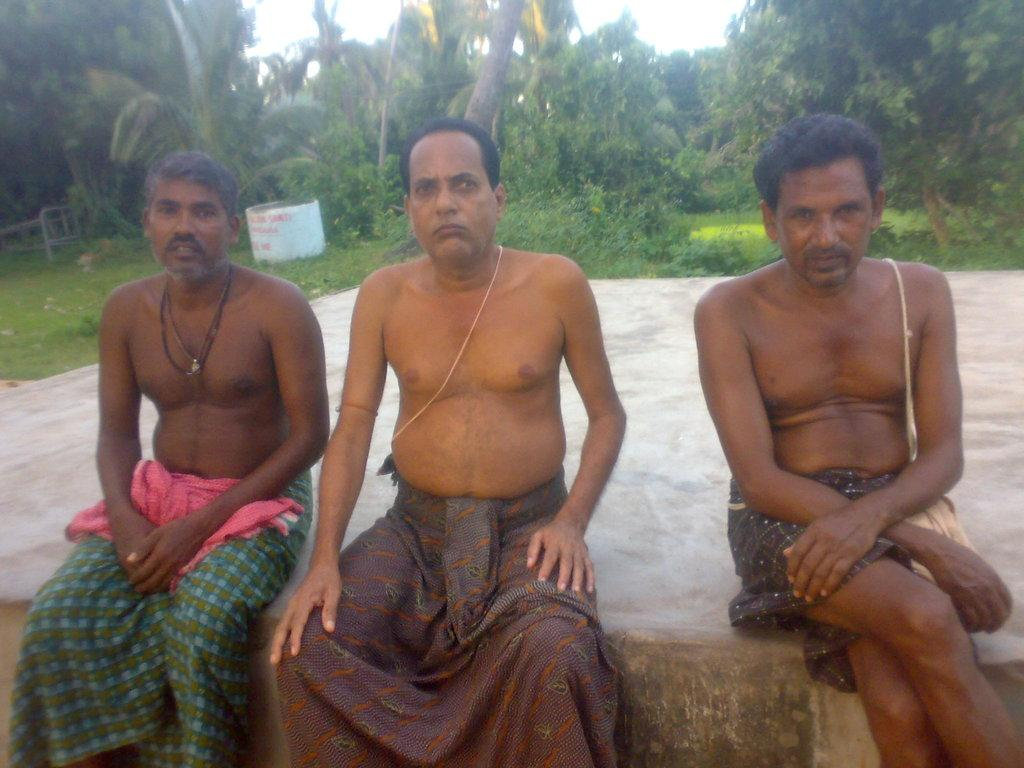How many people are in the image? There are people in the image, but the exact number cannot be determined from the provided facts. What is the primary natural element visible in the image? Water is visible in the image. What type of vegetation can be seen in the image? Trees and grass are visible in the image. What is visible in the background of the image? The sky is visible in the image. What type of brush is being used by the person in the image? There is no person using a brush in the image. What type of pleasure can be derived from the activities depicted in the image? The provided facts do not mention any activities or pleasures associated with the image. 